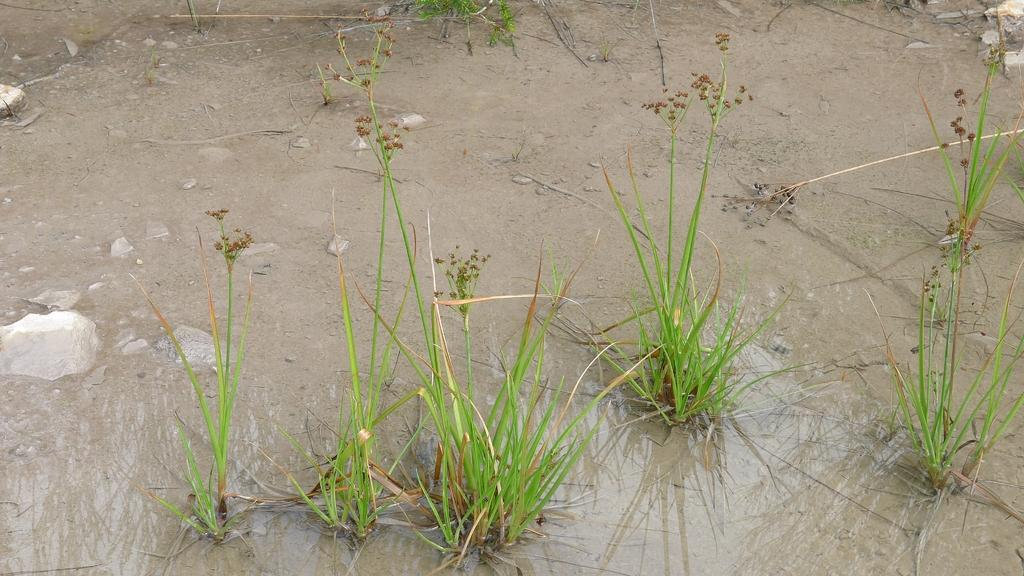What type of terrain is visible at the bottom of the image? There is grass and water at the bottom of the image. Can you describe the grass in the image? The grass is visible at the bottom of the image. What is the water feature in the image? The water is also visible at the bottom of the image. What type of face can be seen in the water at the bottom of the image? There is no face visible in the water at the bottom of the image. What is the tin doing in the grass at the bottom of the image? There is no tin present in the image. 